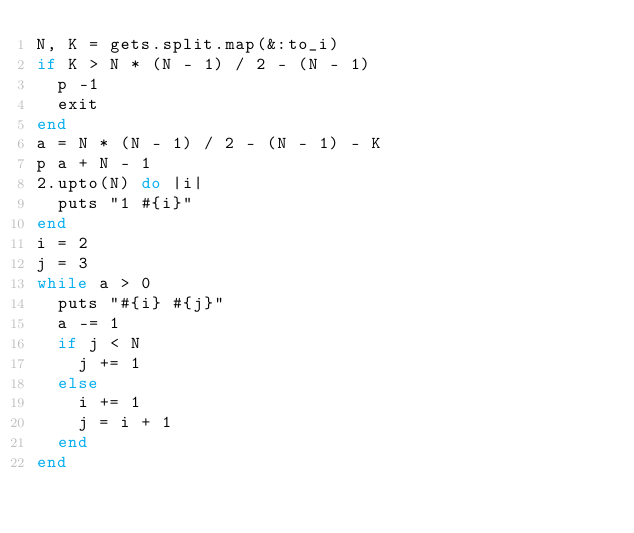Convert code to text. <code><loc_0><loc_0><loc_500><loc_500><_Ruby_>N, K = gets.split.map(&:to_i)
if K > N * (N - 1) / 2 - (N - 1)
  p -1
  exit
end
a = N * (N - 1) / 2 - (N - 1) - K
p a + N - 1
2.upto(N) do |i|
  puts "1 #{i}"
end
i = 2
j = 3
while a > 0
  puts "#{i} #{j}"
  a -= 1
  if j < N
    j += 1
  else
    i += 1
    j = i + 1
  end
end</code> 